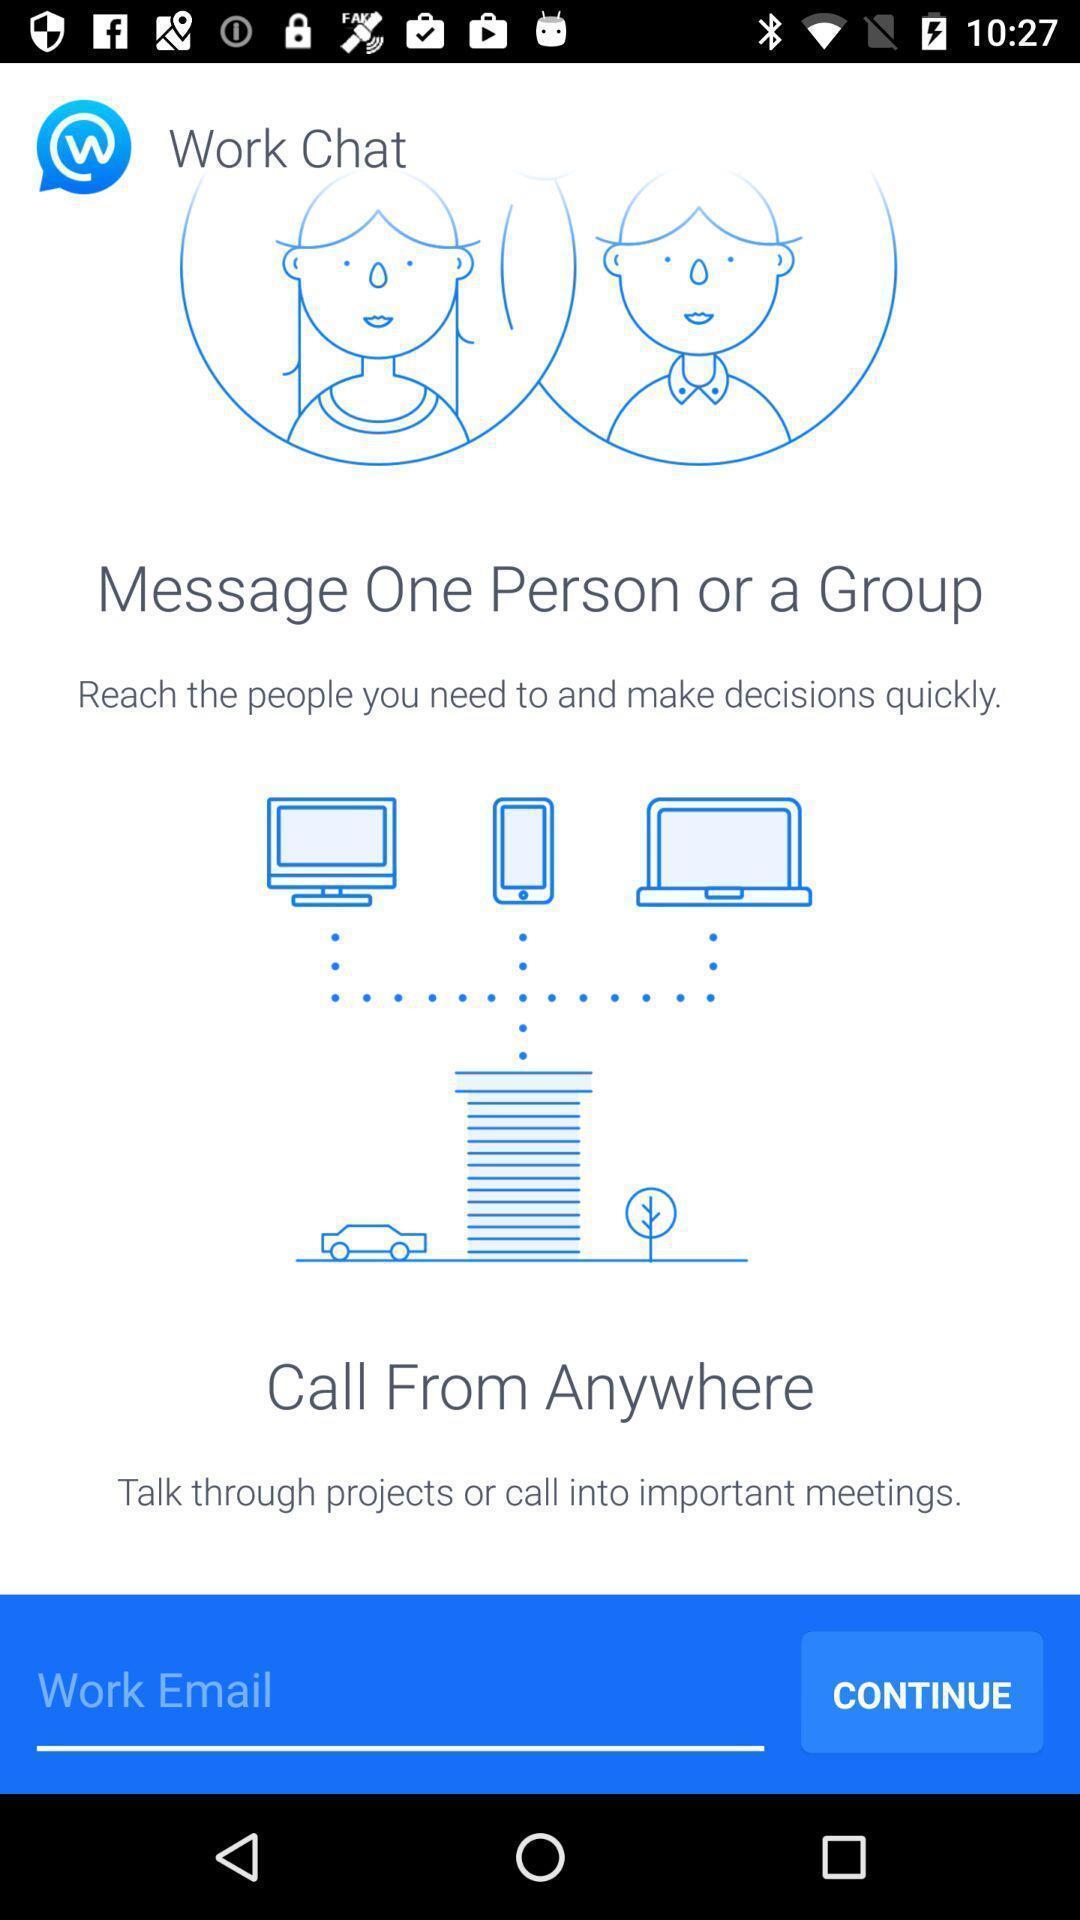What can you discern from this picture? Screen displaying page with continue option. 